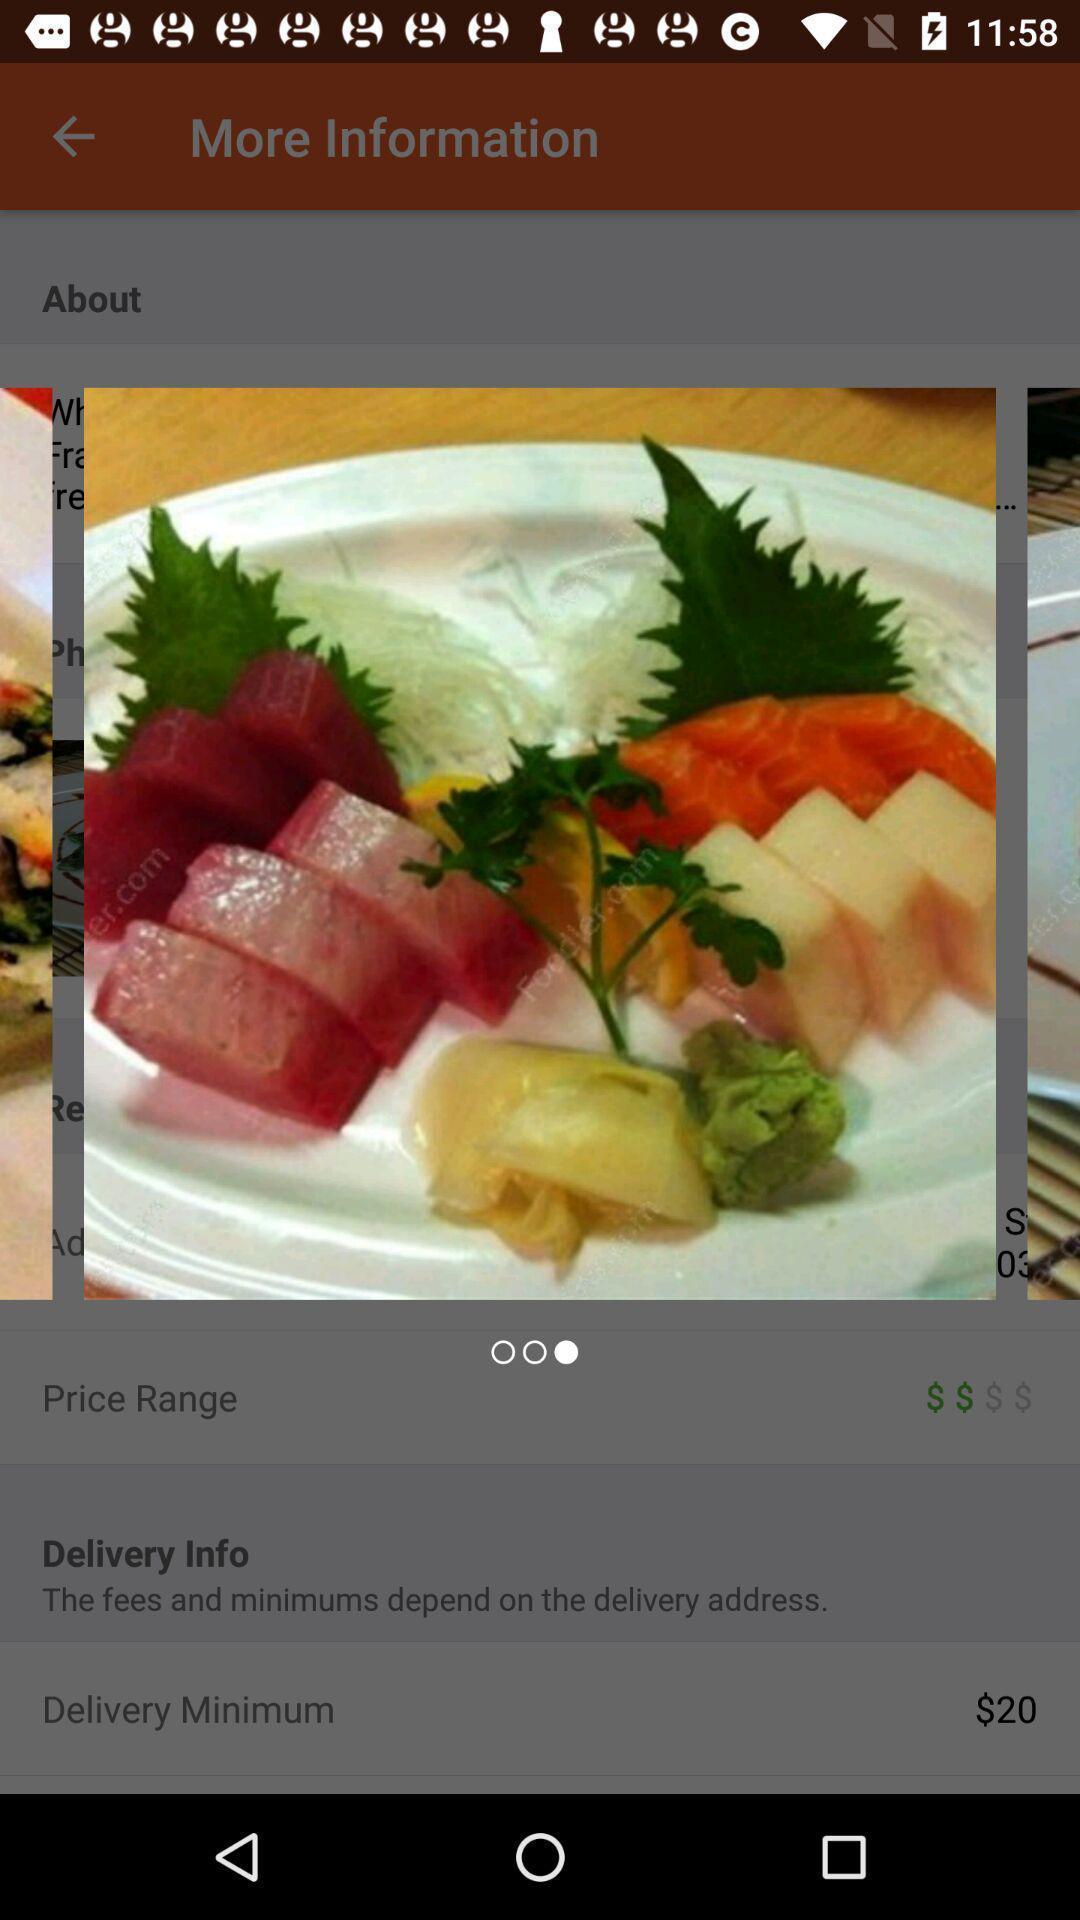What is the overall content of this screenshot? Screen showing image in food app. 